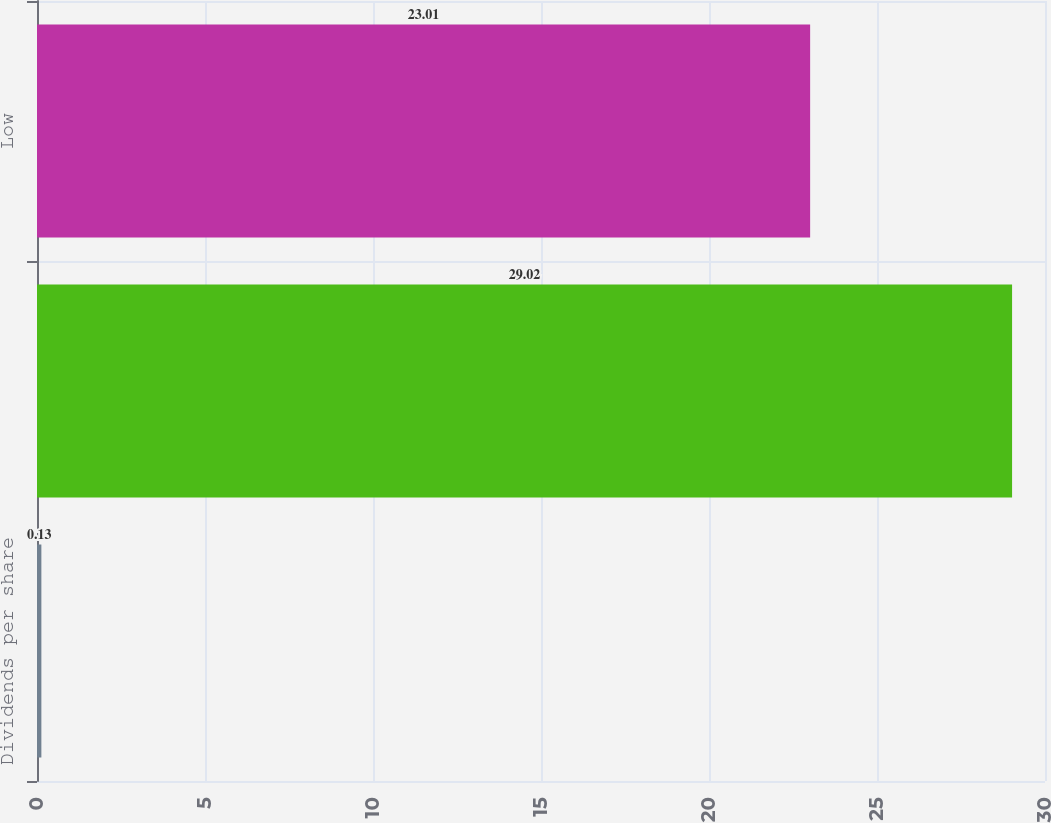Convert chart to OTSL. <chart><loc_0><loc_0><loc_500><loc_500><bar_chart><fcel>Dividends per share<fcel>High<fcel>Low<nl><fcel>0.13<fcel>29.02<fcel>23.01<nl></chart> 